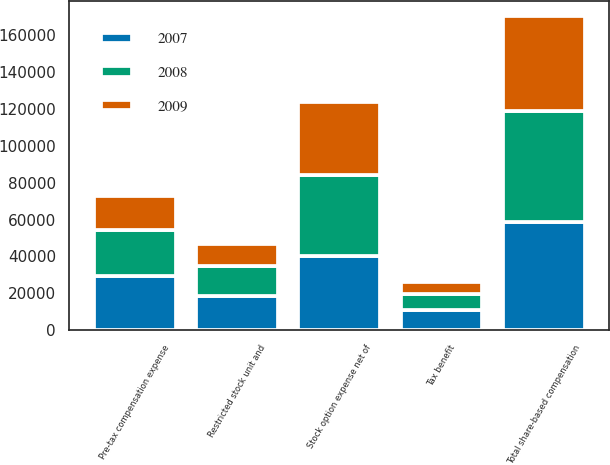Convert chart to OTSL. <chart><loc_0><loc_0><loc_500><loc_500><stacked_bar_chart><ecel><fcel>Pre-tax compensation expense<fcel>Tax benefit<fcel>Restricted stock unit and<fcel>Stock option expense net of<fcel>Total share-based compensation<nl><fcel>2007<fcel>29138<fcel>10853<fcel>18285<fcel>40216<fcel>58501<nl><fcel>2008<fcel>25109<fcel>8789<fcel>16320<fcel>44057<fcel>60377<nl><fcel>2009<fcel>18708<fcel>6548<fcel>12160<fcel>39386<fcel>51546<nl></chart> 